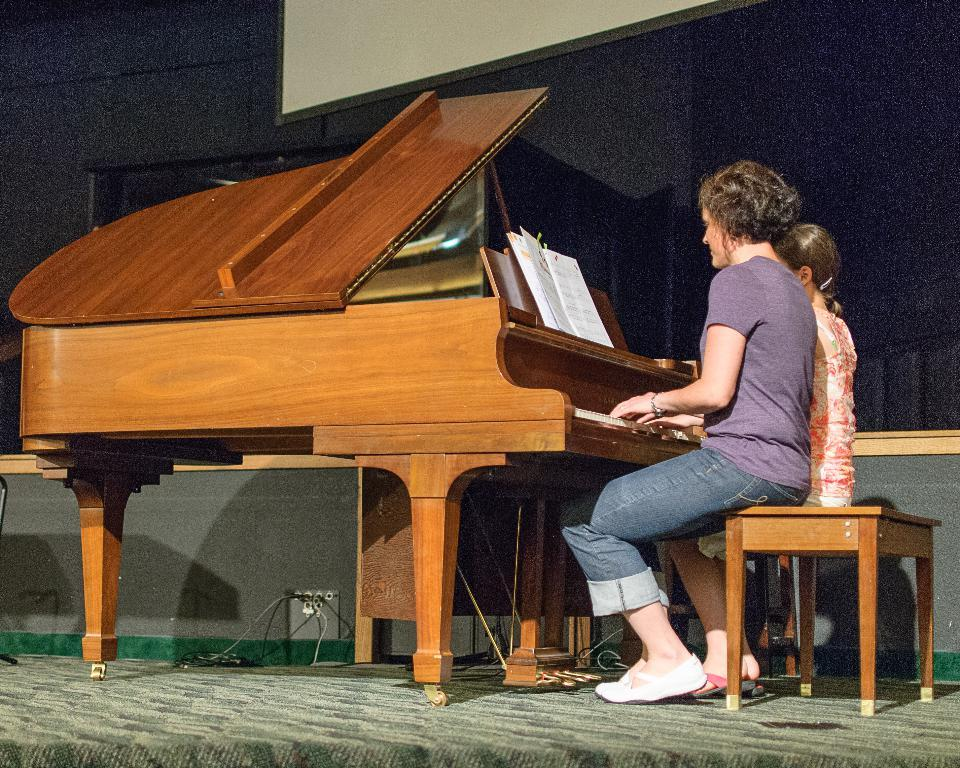What is the person in the image doing? The person is sitting at the piano on the right side of the image. What object is on the piano? There is a book on the piano. What can be seen in the background of the image? There is a door and a wall in the background of the image. What color is the roll of paper on the piano? There is no roll of paper on the piano in the image. 